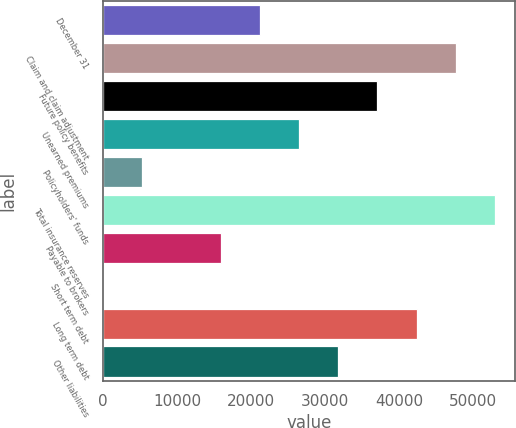Convert chart to OTSL. <chart><loc_0><loc_0><loc_500><loc_500><bar_chart><fcel>December 31<fcel>Claim and claim adjustment<fcel>Future policy benefits<fcel>Unearned premiums<fcel>Policyholders' funds<fcel>Total insurance reserves<fcel>Payable to brokers<fcel>Short term debt<fcel>Long term debt<fcel>Other liabilities<nl><fcel>21200<fcel>47687.5<fcel>37092.5<fcel>26497.5<fcel>5307.5<fcel>52985<fcel>15902.5<fcel>10<fcel>42390<fcel>31795<nl></chart> 